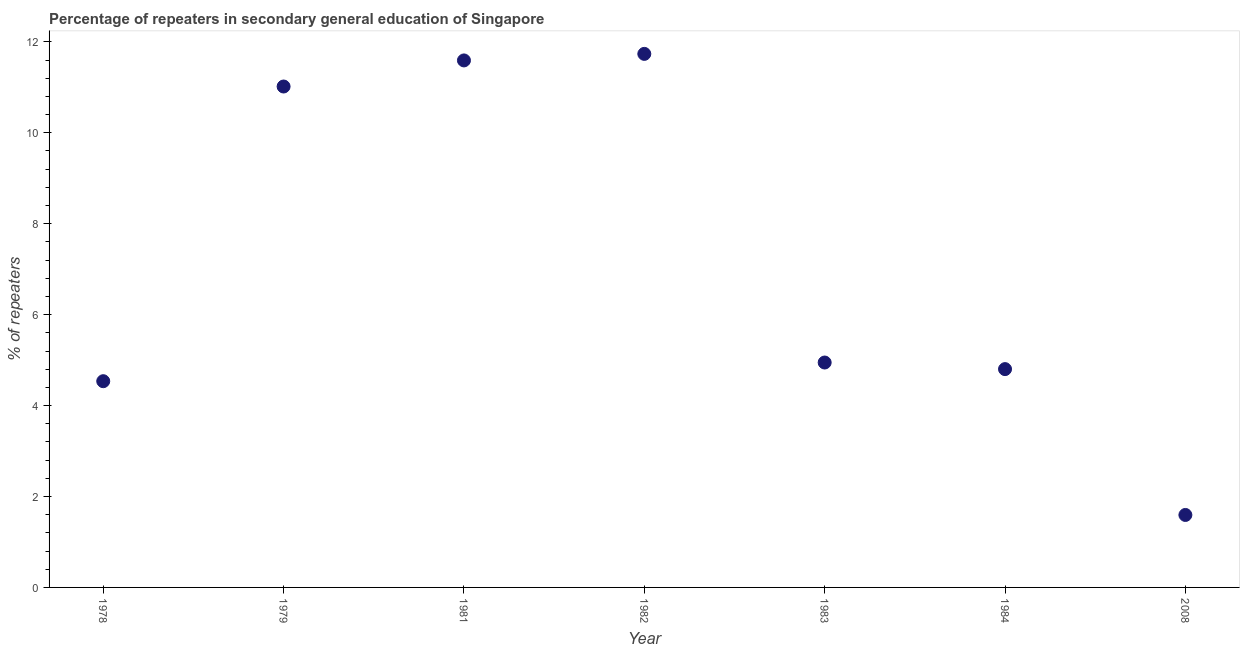What is the percentage of repeaters in 1978?
Provide a short and direct response. 4.54. Across all years, what is the maximum percentage of repeaters?
Provide a short and direct response. 11.74. Across all years, what is the minimum percentage of repeaters?
Offer a terse response. 1.59. In which year was the percentage of repeaters maximum?
Give a very brief answer. 1982. In which year was the percentage of repeaters minimum?
Ensure brevity in your answer.  2008. What is the sum of the percentage of repeaters?
Provide a short and direct response. 50.22. What is the difference between the percentage of repeaters in 1978 and 1981?
Ensure brevity in your answer.  -7.06. What is the average percentage of repeaters per year?
Your answer should be compact. 7.17. What is the median percentage of repeaters?
Provide a short and direct response. 4.95. In how many years, is the percentage of repeaters greater than 4.8 %?
Offer a terse response. 5. Do a majority of the years between 1979 and 2008 (inclusive) have percentage of repeaters greater than 10 %?
Provide a short and direct response. No. What is the ratio of the percentage of repeaters in 1981 to that in 2008?
Offer a terse response. 7.27. What is the difference between the highest and the second highest percentage of repeaters?
Make the answer very short. 0.14. What is the difference between the highest and the lowest percentage of repeaters?
Give a very brief answer. 10.14. In how many years, is the percentage of repeaters greater than the average percentage of repeaters taken over all years?
Make the answer very short. 3. How many years are there in the graph?
Offer a very short reply. 7. Are the values on the major ticks of Y-axis written in scientific E-notation?
Ensure brevity in your answer.  No. Does the graph contain any zero values?
Offer a very short reply. No. What is the title of the graph?
Ensure brevity in your answer.  Percentage of repeaters in secondary general education of Singapore. What is the label or title of the Y-axis?
Your answer should be very brief. % of repeaters. What is the % of repeaters in 1978?
Your answer should be very brief. 4.54. What is the % of repeaters in 1979?
Provide a succinct answer. 11.02. What is the % of repeaters in 1981?
Give a very brief answer. 11.59. What is the % of repeaters in 1982?
Make the answer very short. 11.74. What is the % of repeaters in 1983?
Keep it short and to the point. 4.95. What is the % of repeaters in 1984?
Ensure brevity in your answer.  4.8. What is the % of repeaters in 2008?
Your response must be concise. 1.59. What is the difference between the % of repeaters in 1978 and 1979?
Keep it short and to the point. -6.48. What is the difference between the % of repeaters in 1978 and 1981?
Offer a very short reply. -7.06. What is the difference between the % of repeaters in 1978 and 1982?
Ensure brevity in your answer.  -7.2. What is the difference between the % of repeaters in 1978 and 1983?
Provide a short and direct response. -0.41. What is the difference between the % of repeaters in 1978 and 1984?
Provide a succinct answer. -0.27. What is the difference between the % of repeaters in 1978 and 2008?
Your answer should be compact. 2.94. What is the difference between the % of repeaters in 1979 and 1981?
Ensure brevity in your answer.  -0.57. What is the difference between the % of repeaters in 1979 and 1982?
Give a very brief answer. -0.72. What is the difference between the % of repeaters in 1979 and 1983?
Your answer should be compact. 6.07. What is the difference between the % of repeaters in 1979 and 1984?
Offer a very short reply. 6.22. What is the difference between the % of repeaters in 1979 and 2008?
Provide a short and direct response. 9.42. What is the difference between the % of repeaters in 1981 and 1982?
Offer a terse response. -0.14. What is the difference between the % of repeaters in 1981 and 1983?
Your answer should be very brief. 6.64. What is the difference between the % of repeaters in 1981 and 1984?
Keep it short and to the point. 6.79. What is the difference between the % of repeaters in 1981 and 2008?
Keep it short and to the point. 10. What is the difference between the % of repeaters in 1982 and 1983?
Your answer should be compact. 6.79. What is the difference between the % of repeaters in 1982 and 1984?
Your response must be concise. 6.93. What is the difference between the % of repeaters in 1982 and 2008?
Make the answer very short. 10.14. What is the difference between the % of repeaters in 1983 and 1984?
Give a very brief answer. 0.14. What is the difference between the % of repeaters in 1983 and 2008?
Ensure brevity in your answer.  3.35. What is the difference between the % of repeaters in 1984 and 2008?
Provide a short and direct response. 3.21. What is the ratio of the % of repeaters in 1978 to that in 1979?
Make the answer very short. 0.41. What is the ratio of the % of repeaters in 1978 to that in 1981?
Provide a succinct answer. 0.39. What is the ratio of the % of repeaters in 1978 to that in 1982?
Give a very brief answer. 0.39. What is the ratio of the % of repeaters in 1978 to that in 1983?
Give a very brief answer. 0.92. What is the ratio of the % of repeaters in 1978 to that in 1984?
Provide a short and direct response. 0.94. What is the ratio of the % of repeaters in 1978 to that in 2008?
Make the answer very short. 2.85. What is the ratio of the % of repeaters in 1979 to that in 1981?
Provide a short and direct response. 0.95. What is the ratio of the % of repeaters in 1979 to that in 1982?
Your answer should be very brief. 0.94. What is the ratio of the % of repeaters in 1979 to that in 1983?
Keep it short and to the point. 2.23. What is the ratio of the % of repeaters in 1979 to that in 1984?
Keep it short and to the point. 2.29. What is the ratio of the % of repeaters in 1979 to that in 2008?
Keep it short and to the point. 6.91. What is the ratio of the % of repeaters in 1981 to that in 1983?
Give a very brief answer. 2.34. What is the ratio of the % of repeaters in 1981 to that in 1984?
Give a very brief answer. 2.41. What is the ratio of the % of repeaters in 1981 to that in 2008?
Provide a succinct answer. 7.27. What is the ratio of the % of repeaters in 1982 to that in 1983?
Your answer should be compact. 2.37. What is the ratio of the % of repeaters in 1982 to that in 1984?
Offer a terse response. 2.44. What is the ratio of the % of repeaters in 1982 to that in 2008?
Your answer should be compact. 7.36. What is the ratio of the % of repeaters in 1983 to that in 1984?
Offer a terse response. 1.03. What is the ratio of the % of repeaters in 1983 to that in 2008?
Offer a very short reply. 3.1. What is the ratio of the % of repeaters in 1984 to that in 2008?
Ensure brevity in your answer.  3.01. 